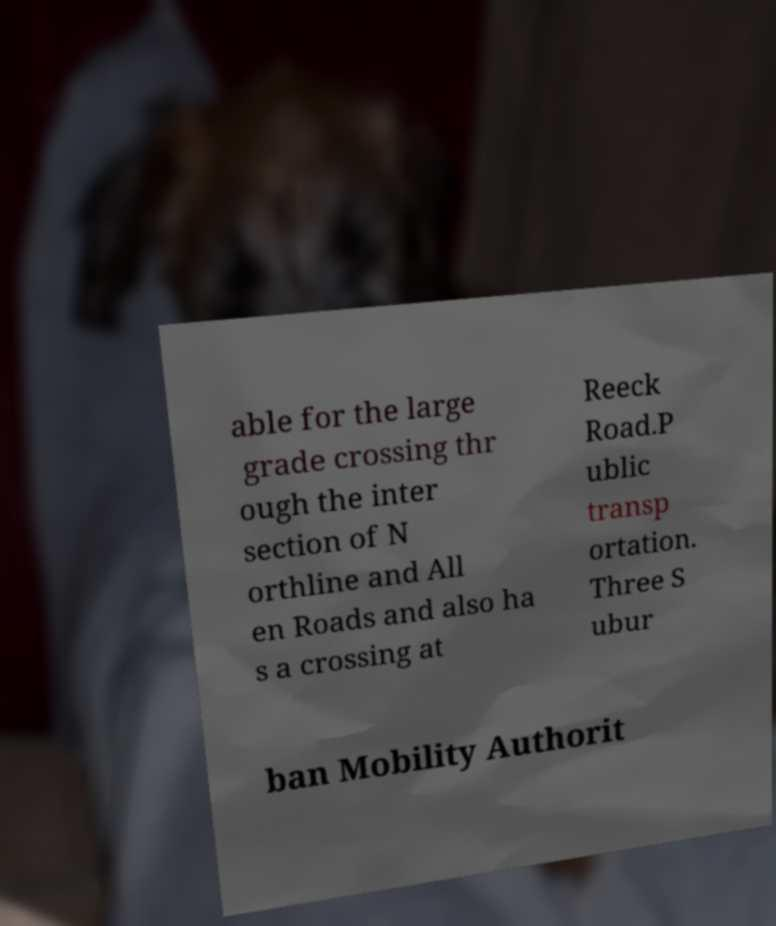Could you extract and type out the text from this image? able for the large grade crossing thr ough the inter section of N orthline and All en Roads and also ha s a crossing at Reeck Road.P ublic transp ortation. Three S ubur ban Mobility Authorit 